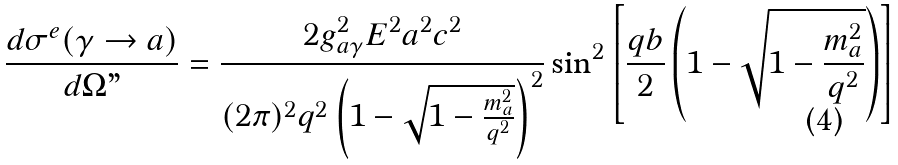<formula> <loc_0><loc_0><loc_500><loc_500>\frac { d \sigma ^ { e } ( \gamma \rightarrow a ) } { d \Omega " } = \frac { 2 g ^ { 2 } _ { a \gamma } E ^ { 2 } a ^ { 2 } c ^ { 2 } } { ( 2 \pi ) ^ { 2 } q ^ { 2 } \left ( 1 - \sqrt { 1 - \frac { m ^ { 2 } _ { a } } { q ^ { 2 } } } \right ) ^ { 2 } } \sin ^ { 2 } \left [ \frac { q b } { 2 } \left ( 1 - \sqrt { 1 - \frac { m ^ { 2 } _ { a } } { q ^ { 2 } } } \right ) \right ]</formula> 